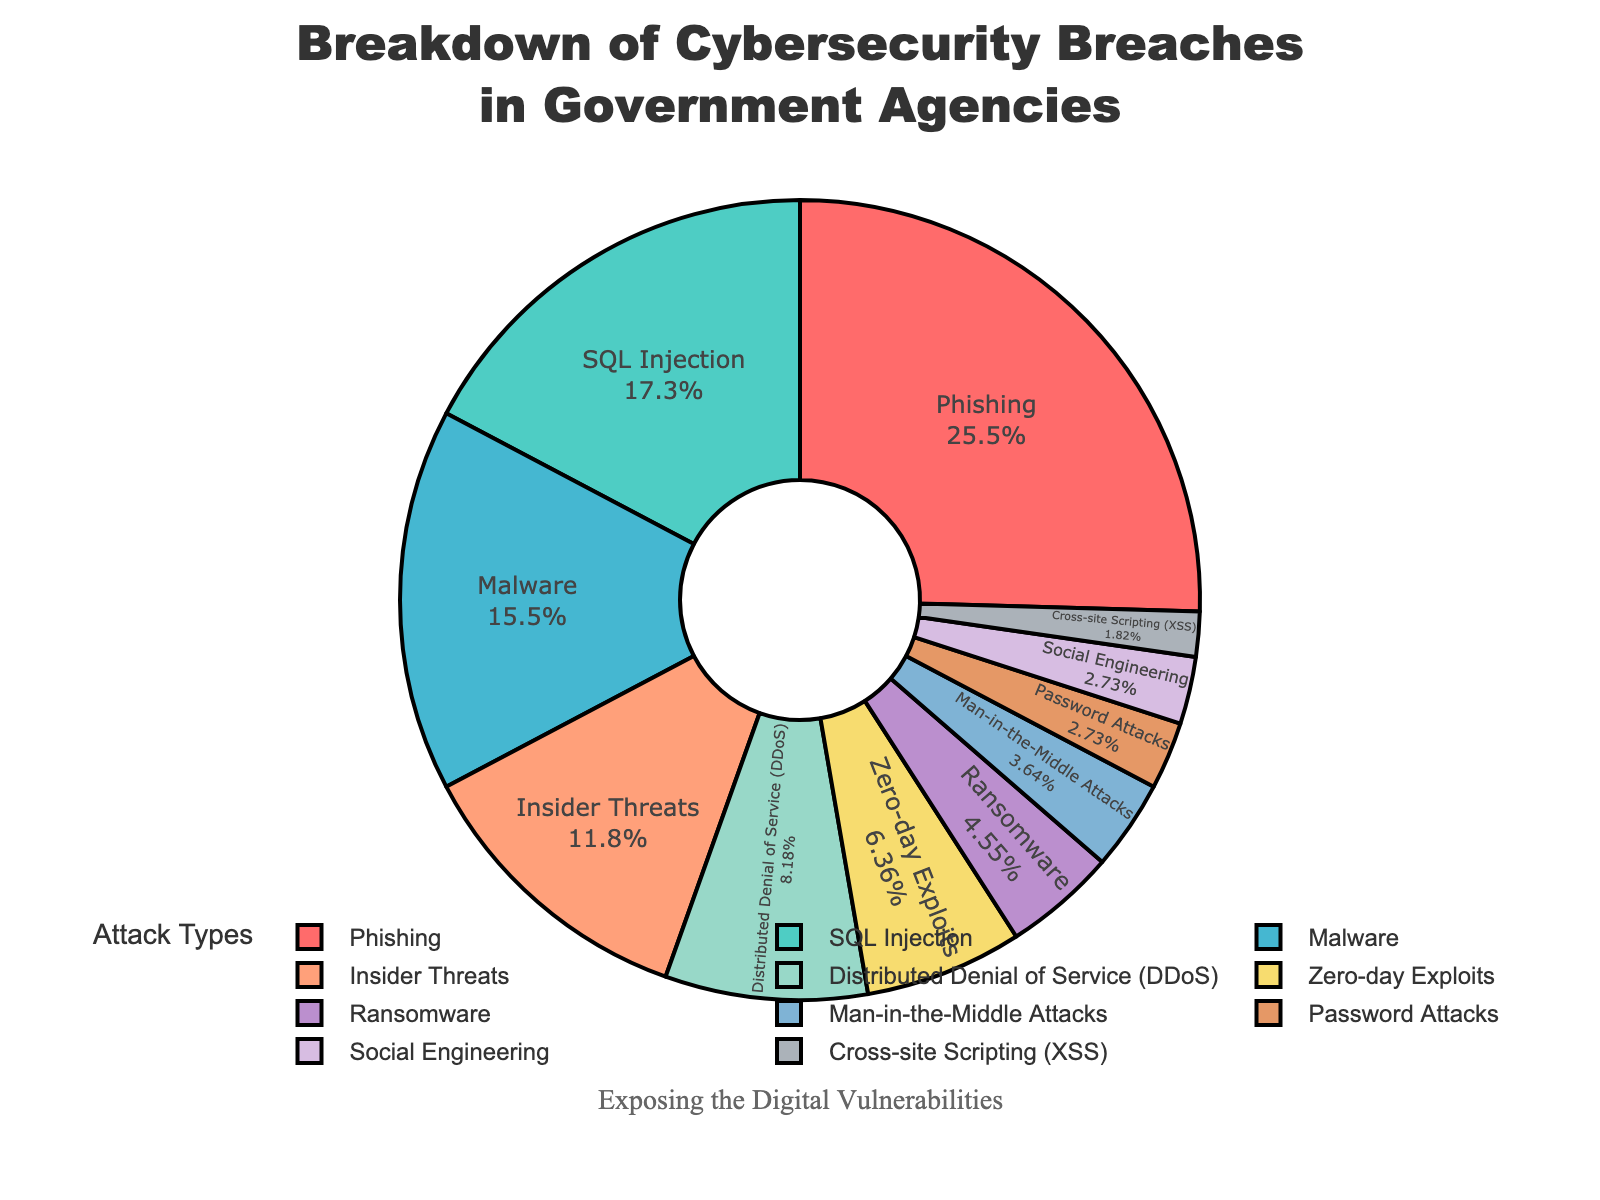What is the most common type of cybersecurity breach in government agencies? To find the most common type, look for the segment with the highest percentage. Phishing has 28%, which is the highest.
Answer: Phishing Which attack types together make up more than 50% of the total breaches? Add the percentages of the largest categories until the sum exceeds 50%. Phishing (28%) + SQL Injection (19%) + Malware (17%) = 64%.
Answer: Phishing, SQL Injection, and Malware How does the percentage of DDoS attacks compare to Malware attacks? Compare the two percentages: DDoS is 9%, and Malware is 17%. 9% is lower than 17%.
Answer: DDoS attacks are less common than Malware attacks Which attack type is represented by a dark blue segment in the pie chart? Identify the color coding; the dark blue segment corresponds to SQL Injection.
Answer: SQL Injection What percentage of breaches is due to Zero-day Exploits? Locate the segment labeled Zero-day Exploits and read its percentage, which is 7%.
Answer: 7% If we combine the percentages of Password Attacks and Social Engineering, what is the total? Add the percentage of Password Attacks (3%) and Social Engineering (3%). 3% + 3% = 6%.
Answer: 6% Which is more common, Insider Threats or Ransomware, and by how much? Compare the percentages: Insider Threats (13%) and Ransomware (5%). Calculate the difference: 13% - 5% = 8%.
Answer: Insider Threats by 8% How many attack types make up less than 10% each of the total breaches? Count the categories with percentages less than 10%. DDoS (9%), Zero-day Exploits (7%), Ransomware (5%), Man-in-the-Middle Attacks (4%), Password Attacks (3%), Social Engineering (3%), Cross-site Scripting (XSS) (2%). This equals 7 categories.
Answer: 7 What is the combined total percentage for all attack types that form less than 5% each of the total breaches? Add the percentages for categories below 5%: Man-in-the-Middle Attacks (4%) + Password Attacks (3%) + Social Engineering (3%) + Cross-site Scripting (XSS) (2%). Total: 4% + 3% + 3% + 2% = 12%.
Answer: 12% When summing the percentages of SQL Injection and Phishing, what proportion of the total breaches does it represent? Add the percentages: SQL Injection (19%) + Phishing (28%). Sum = 19% + 28% = 47%.
Answer: 47% 